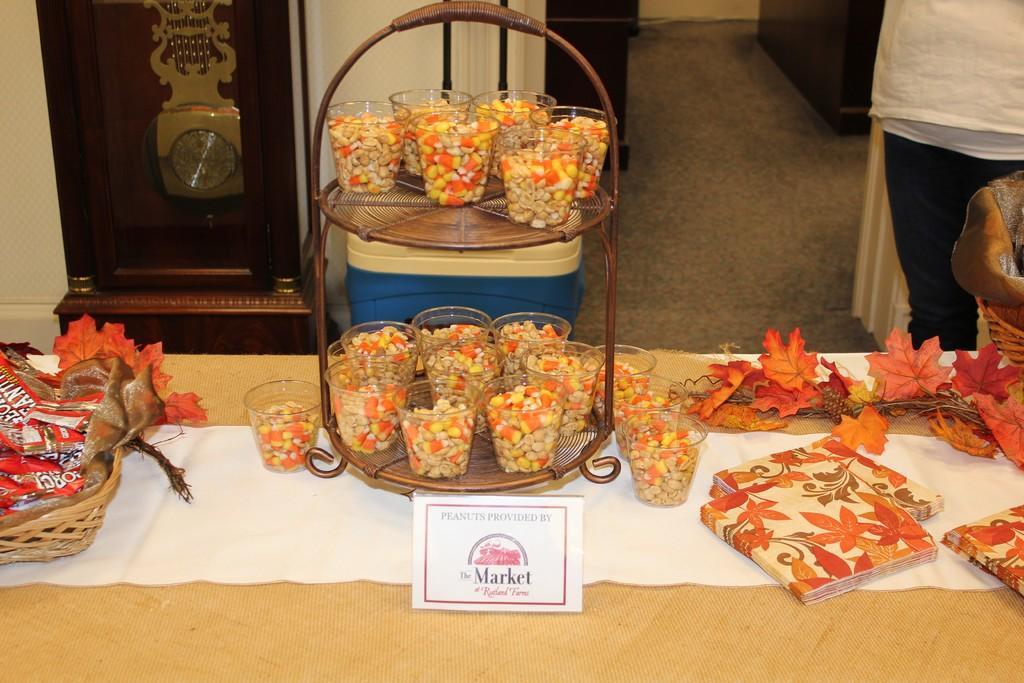Describe this image in one or two sentences. In this image I can see a decorated table with some baskets and glasses with nuts and I can see some books. I can see a name plate with some text at the bottom of the image. I can see a person standing behind. 